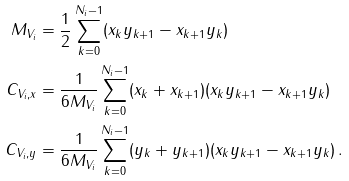<formula> <loc_0><loc_0><loc_500><loc_500>M _ { V _ { i } } & = \frac { 1 } { 2 } \sum _ { k = 0 } ^ { N _ { i } - 1 } ( x _ { k } y _ { k + 1 } - x _ { k + 1 } y _ { k } ) \\ C _ { { V _ { i } } , x } & = \frac { 1 } { 6 M _ { V _ { i } } } \sum _ { k = 0 } ^ { N _ { i } - 1 } ( x _ { k } + x _ { k + 1 } ) ( x _ { k } y _ { k + 1 } - x _ { k + 1 } y _ { k } ) \\ C _ { { V _ { i } } , y } & = \frac { 1 } { 6 M _ { V _ { i } } } \sum _ { k = 0 } ^ { N _ { i } - 1 } ( y _ { k } + y _ { k + 1 } ) ( x _ { k } y _ { k + 1 } - x _ { k + 1 } y _ { k } ) \, .</formula> 